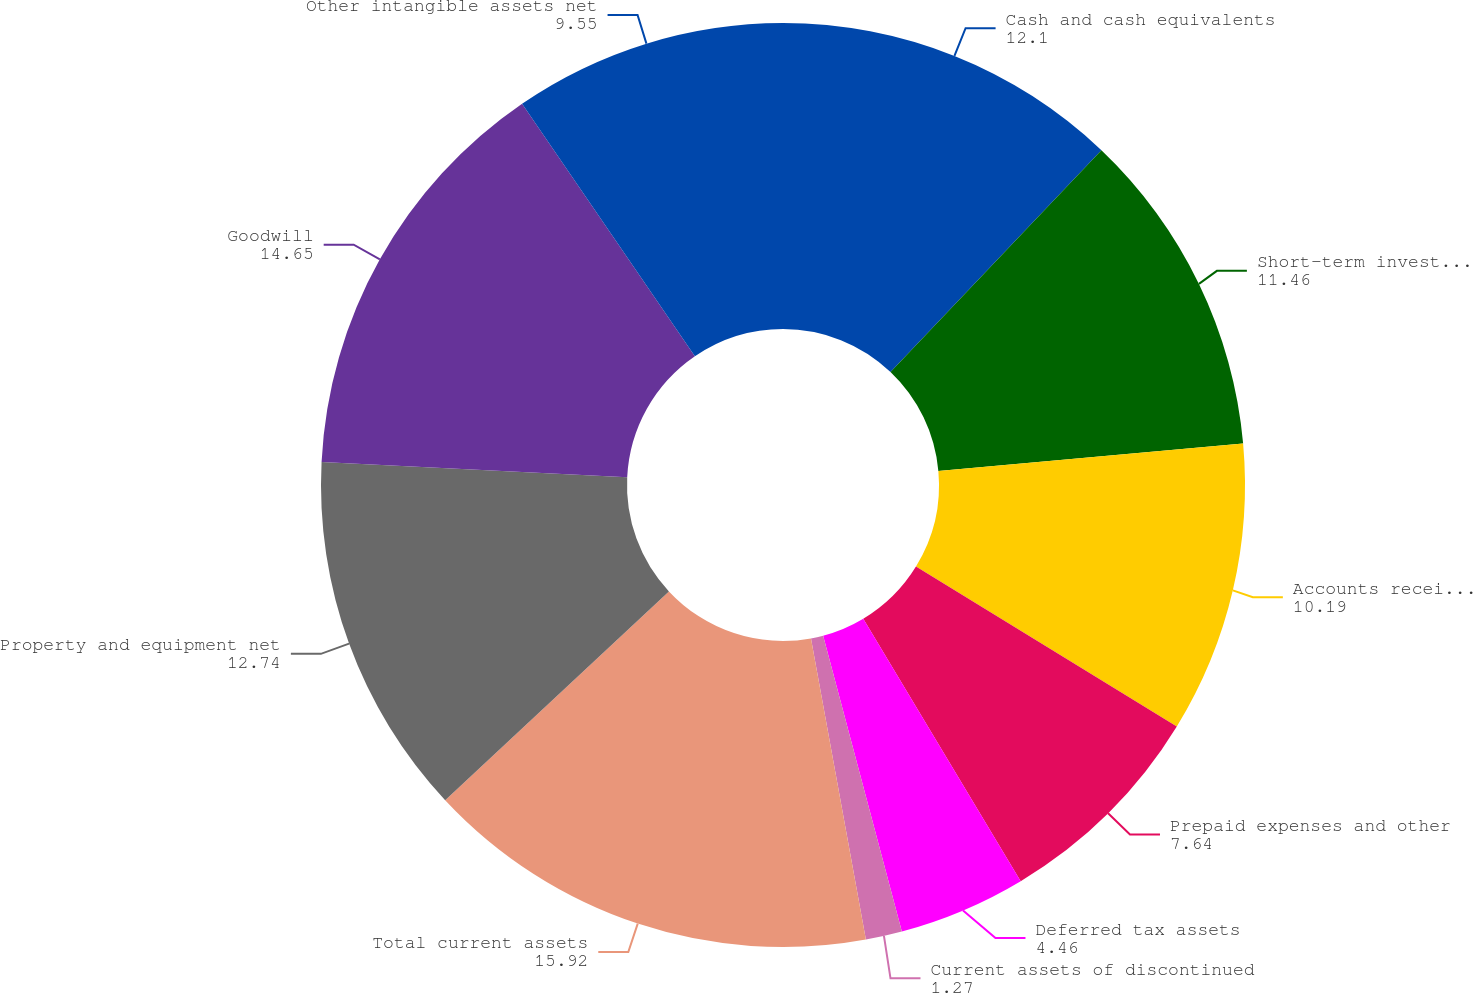Convert chart. <chart><loc_0><loc_0><loc_500><loc_500><pie_chart><fcel>Cash and cash equivalents<fcel>Short-term investments<fcel>Accounts receivable net of<fcel>Prepaid expenses and other<fcel>Deferred tax assets<fcel>Current assets of discontinued<fcel>Total current assets<fcel>Property and equipment net<fcel>Goodwill<fcel>Other intangible assets net<nl><fcel>12.1%<fcel>11.46%<fcel>10.19%<fcel>7.64%<fcel>4.46%<fcel>1.27%<fcel>15.92%<fcel>12.74%<fcel>14.65%<fcel>9.55%<nl></chart> 